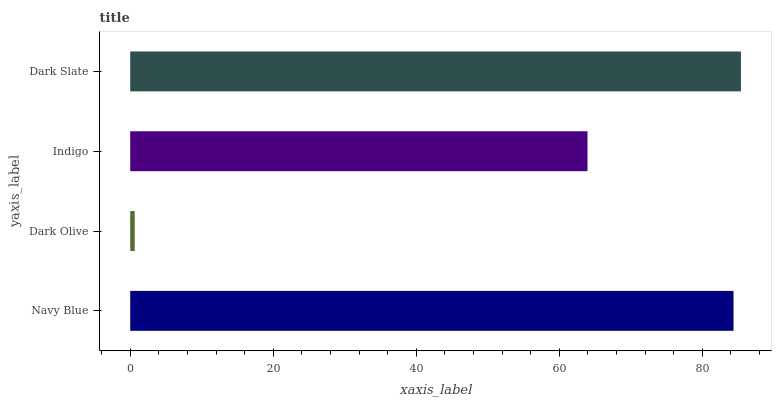Is Dark Olive the minimum?
Answer yes or no. Yes. Is Dark Slate the maximum?
Answer yes or no. Yes. Is Indigo the minimum?
Answer yes or no. No. Is Indigo the maximum?
Answer yes or no. No. Is Indigo greater than Dark Olive?
Answer yes or no. Yes. Is Dark Olive less than Indigo?
Answer yes or no. Yes. Is Dark Olive greater than Indigo?
Answer yes or no. No. Is Indigo less than Dark Olive?
Answer yes or no. No. Is Navy Blue the high median?
Answer yes or no. Yes. Is Indigo the low median?
Answer yes or no. Yes. Is Indigo the high median?
Answer yes or no. No. Is Dark Olive the low median?
Answer yes or no. No. 